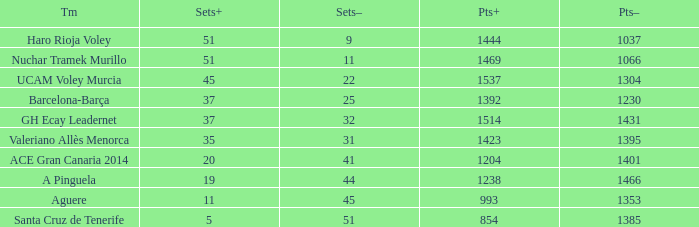What is the highest Points+ number when the Points- number is larger than 1385, a Sets+ number smaller than 37 and a Sets- number larger than 41? 1238.0. 